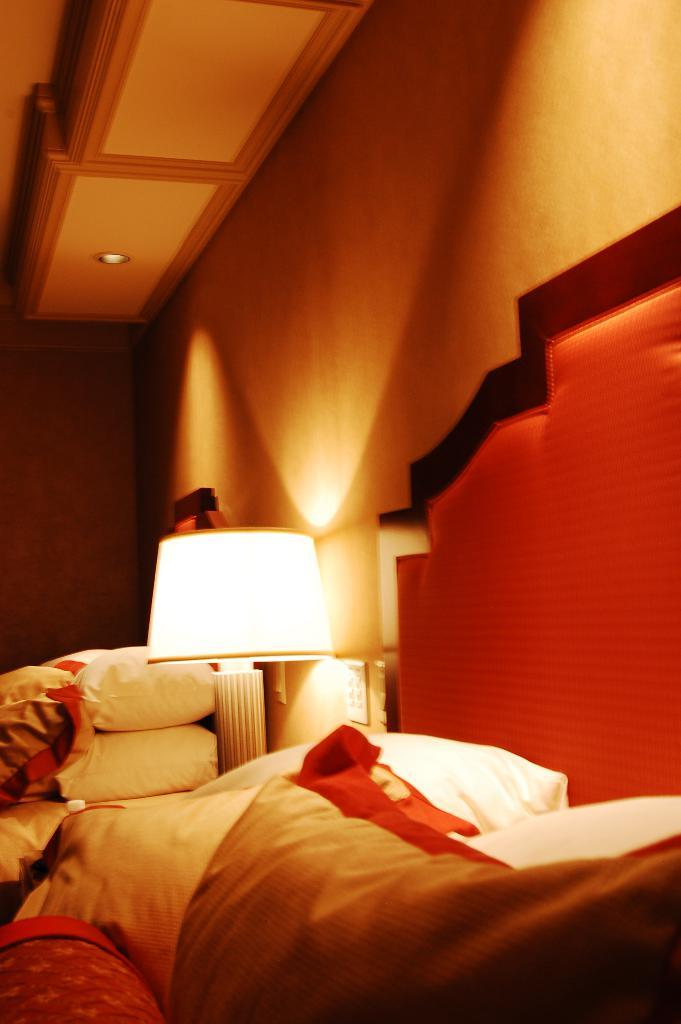What type of space is shown in the image? The image depicts an inside view of a room. What furniture is present in the room? There is a bed in the room. What are some additional items in the room? There are pillows and lights in the room. What type of flower is growing on the bed in the image? There is no flower growing on the bed in the image; it only shows a bed, pillows, and lights. 